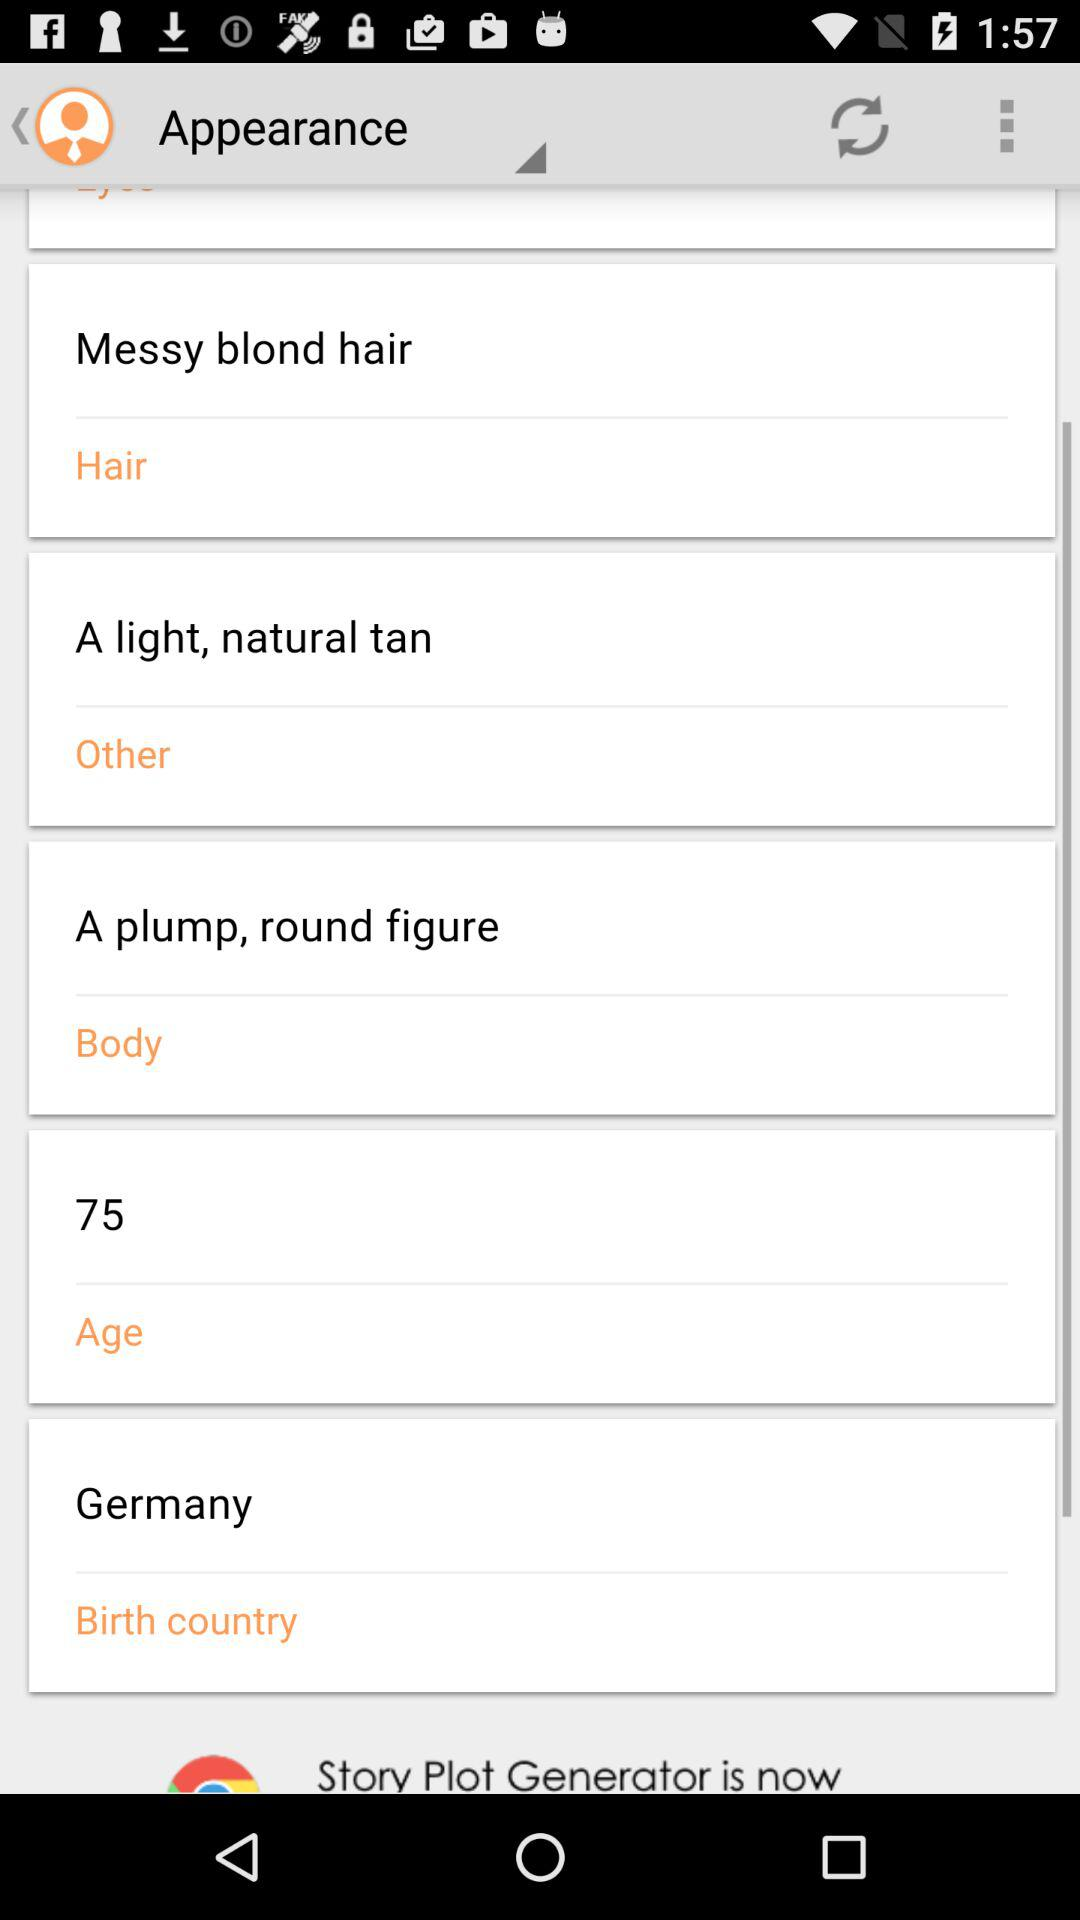What is the birth country? The birth country is Germany. 